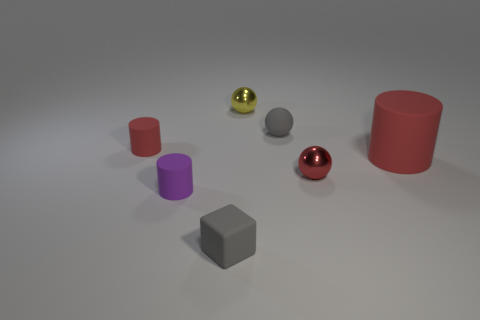Subtract all small matte cylinders. How many cylinders are left? 1 Subtract all red cylinders. How many cylinders are left? 1 Subtract 1 cylinders. How many cylinders are left? 2 Add 2 red cylinders. How many objects exist? 9 Subtract all yellow blocks. How many yellow balls are left? 1 Subtract all cyan blocks. Subtract all green balls. How many blocks are left? 1 Subtract all large yellow metal balls. Subtract all big red cylinders. How many objects are left? 6 Add 5 tiny gray matte cubes. How many tiny gray matte cubes are left? 6 Add 6 tiny matte cylinders. How many tiny matte cylinders exist? 8 Subtract 0 brown cubes. How many objects are left? 7 